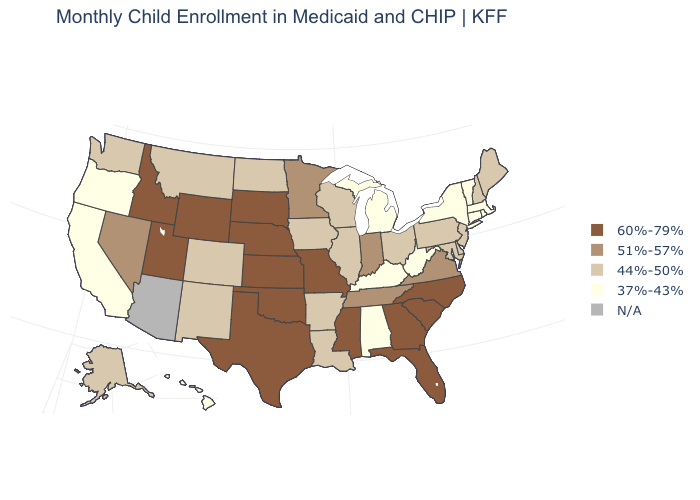What is the value of Idaho?
Give a very brief answer. 60%-79%. Among the states that border North Carolina , does Virginia have the highest value?
Quick response, please. No. Name the states that have a value in the range 37%-43%?
Answer briefly. Alabama, California, Connecticut, Hawaii, Kentucky, Massachusetts, Michigan, New York, Oregon, Rhode Island, Vermont, West Virginia. What is the value of Maine?
Keep it brief. 44%-50%. What is the highest value in the MidWest ?
Short answer required. 60%-79%. Name the states that have a value in the range N/A?
Concise answer only. Arizona. What is the value of Maine?
Write a very short answer. 44%-50%. Name the states that have a value in the range 51%-57%?
Quick response, please. Indiana, Minnesota, Nevada, Tennessee, Virginia. Which states have the highest value in the USA?
Concise answer only. Florida, Georgia, Idaho, Kansas, Mississippi, Missouri, Nebraska, North Carolina, Oklahoma, South Carolina, South Dakota, Texas, Utah, Wyoming. Name the states that have a value in the range 51%-57%?
Keep it brief. Indiana, Minnesota, Nevada, Tennessee, Virginia. Which states have the highest value in the USA?
Be succinct. Florida, Georgia, Idaho, Kansas, Mississippi, Missouri, Nebraska, North Carolina, Oklahoma, South Carolina, South Dakota, Texas, Utah, Wyoming. What is the highest value in the USA?
Short answer required. 60%-79%. Name the states that have a value in the range 37%-43%?
Concise answer only. Alabama, California, Connecticut, Hawaii, Kentucky, Massachusetts, Michigan, New York, Oregon, Rhode Island, Vermont, West Virginia. Does South Carolina have the highest value in the South?
Write a very short answer. Yes. 